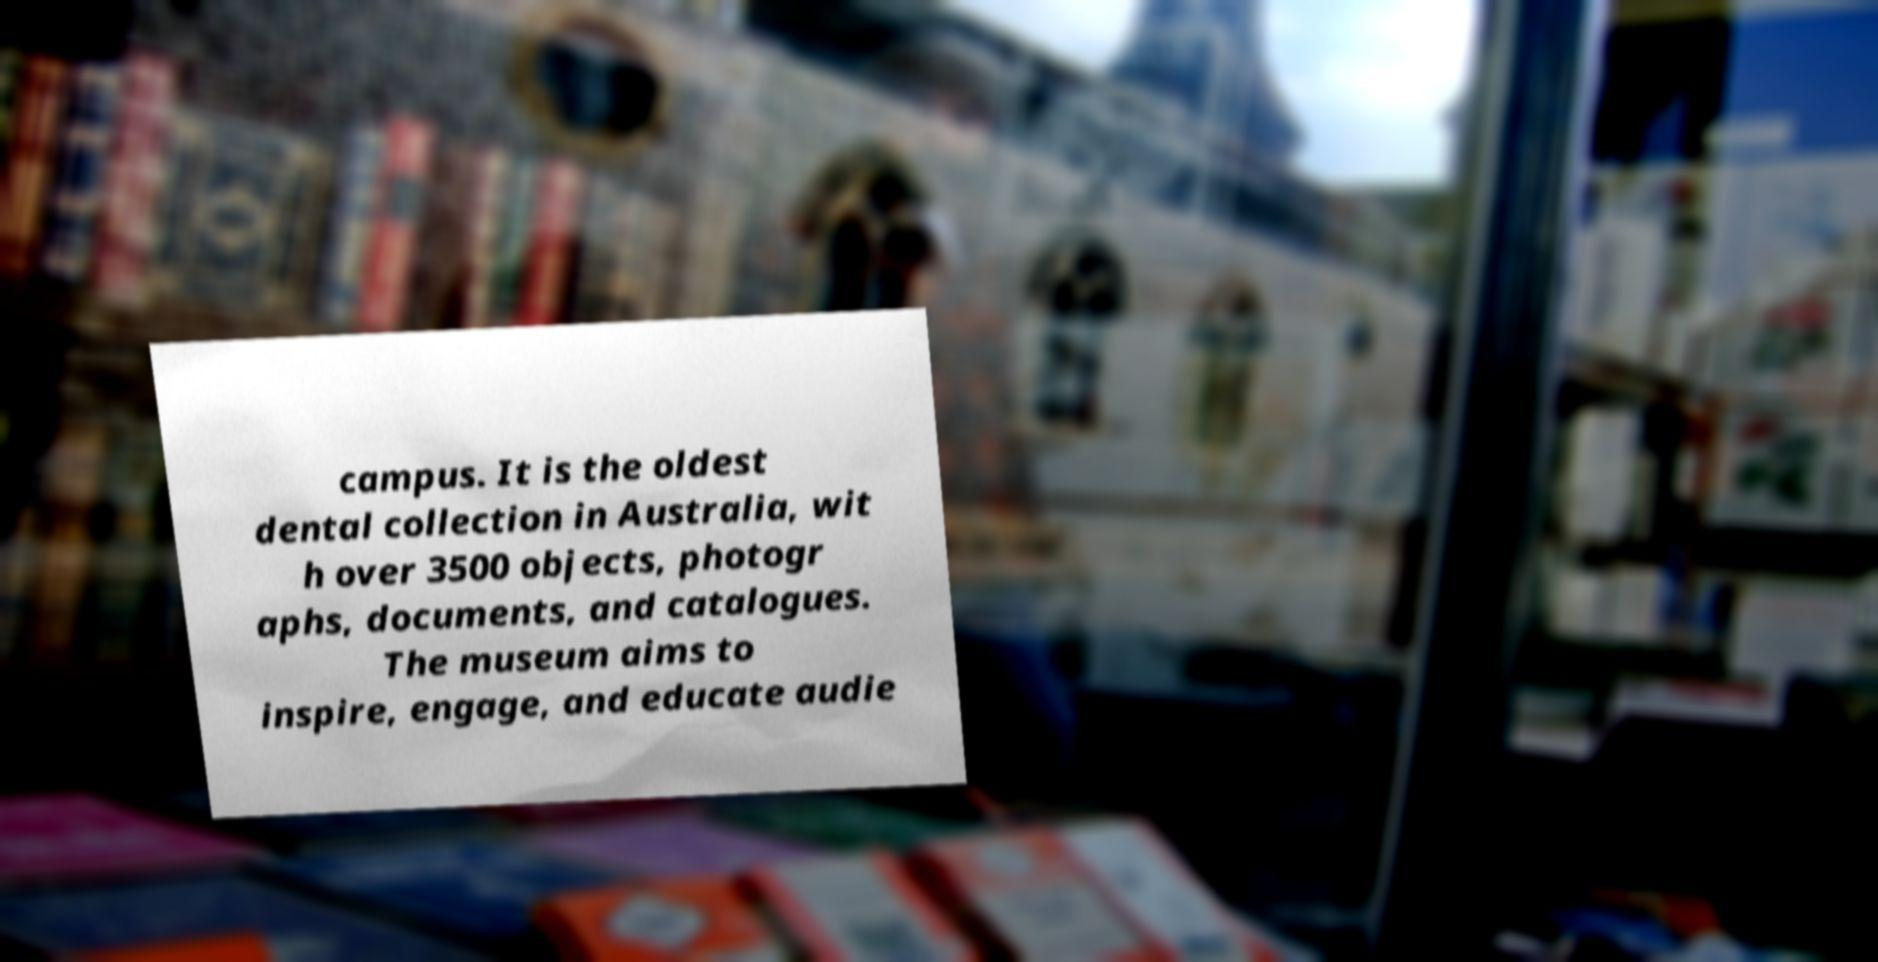For documentation purposes, I need the text within this image transcribed. Could you provide that? campus. It is the oldest dental collection in Australia, wit h over 3500 objects, photogr aphs, documents, and catalogues. The museum aims to inspire, engage, and educate audie 